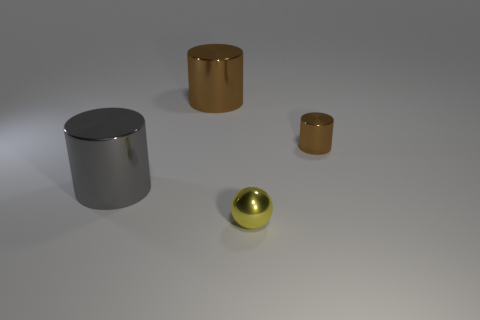Add 2 yellow spheres. How many objects exist? 6 Subtract all balls. How many objects are left? 3 Subtract all small metallic objects. Subtract all small blue cylinders. How many objects are left? 2 Add 1 small balls. How many small balls are left? 2 Add 1 big balls. How many big balls exist? 1 Subtract 1 gray cylinders. How many objects are left? 3 